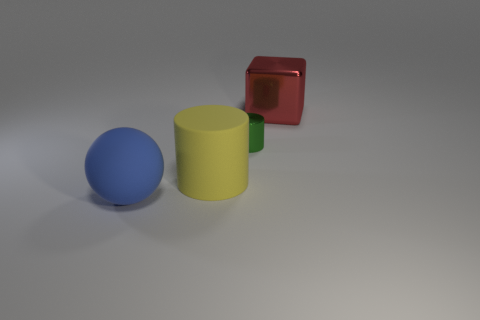Add 2 green matte spheres. How many objects exist? 6 Subtract all spheres. How many objects are left? 3 Subtract 1 blue spheres. How many objects are left? 3 Subtract all big yellow matte things. Subtract all red metallic objects. How many objects are left? 2 Add 3 metal things. How many metal things are left? 5 Add 4 small metal cylinders. How many small metal cylinders exist? 5 